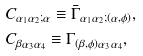Convert formula to latex. <formula><loc_0><loc_0><loc_500><loc_500>& C _ { \alpha _ { 1 } \alpha _ { 2 } ; \alpha } \equiv \bar { \Gamma } _ { \alpha _ { 1 } \alpha _ { 2 } ; ( \alpha , \phi ) } , \\ & C _ { \beta \alpha _ { 3 } \alpha _ { 4 } } \equiv \Gamma _ { ( \beta , \phi ) \alpha _ { 3 } \alpha _ { 4 } } ,</formula> 